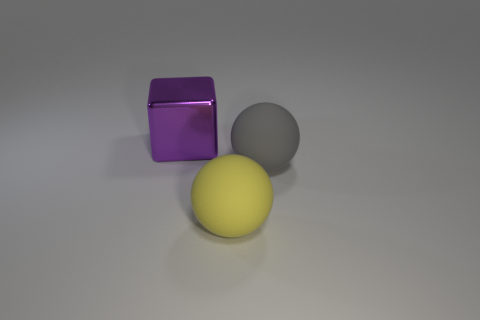Subtract all gray spheres. How many spheres are left? 1 Subtract all blocks. How many objects are left? 2 Subtract all red cubes. How many gray spheres are left? 1 Subtract 0 cyan cylinders. How many objects are left? 3 Subtract 2 balls. How many balls are left? 0 Subtract all red balls. Subtract all purple cylinders. How many balls are left? 2 Subtract all big purple matte cylinders. Subtract all rubber balls. How many objects are left? 1 Add 1 large metallic blocks. How many large metallic blocks are left? 2 Add 2 big balls. How many big balls exist? 4 Add 3 big green matte balls. How many objects exist? 6 